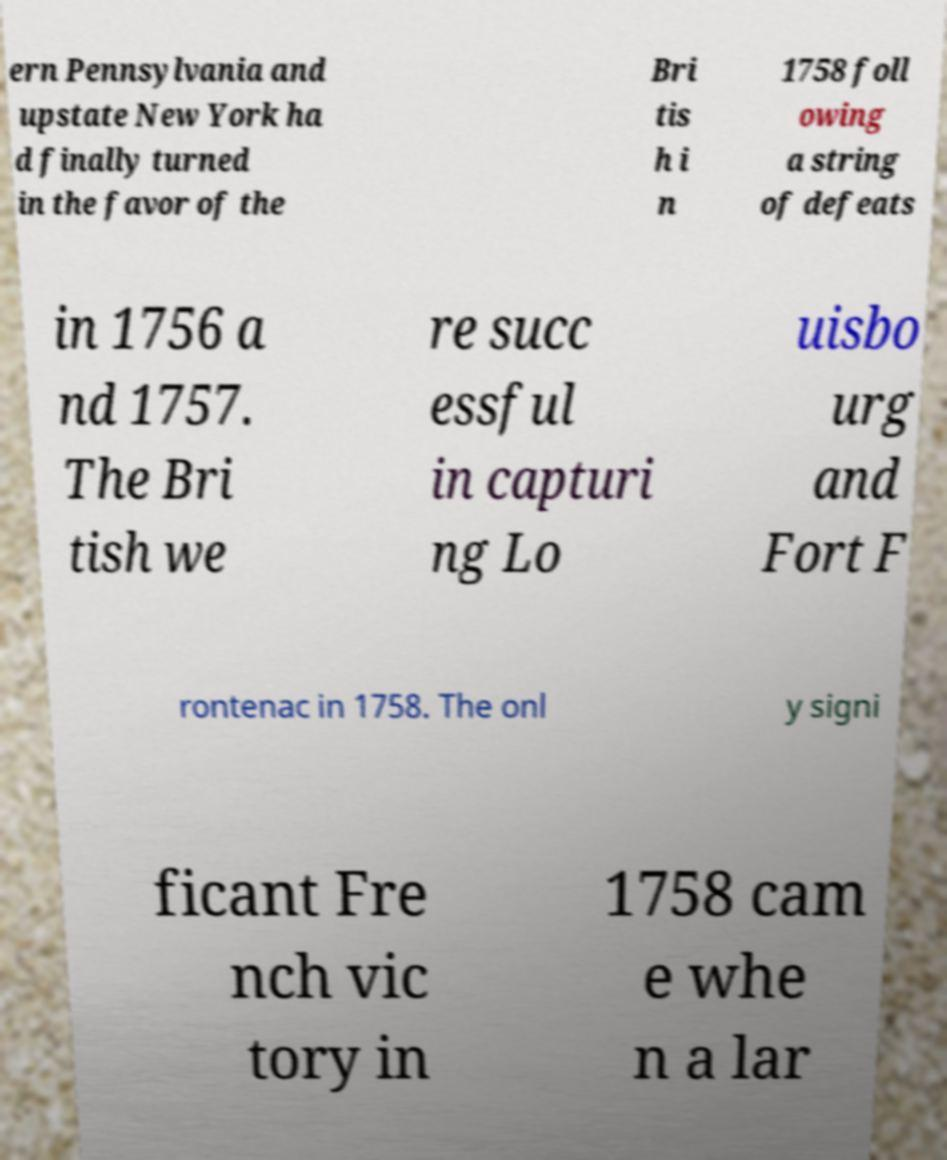What messages or text are displayed in this image? I need them in a readable, typed format. ern Pennsylvania and upstate New York ha d finally turned in the favor of the Bri tis h i n 1758 foll owing a string of defeats in 1756 a nd 1757. The Bri tish we re succ essful in capturi ng Lo uisbo urg and Fort F rontenac in 1758. The onl y signi ficant Fre nch vic tory in 1758 cam e whe n a lar 